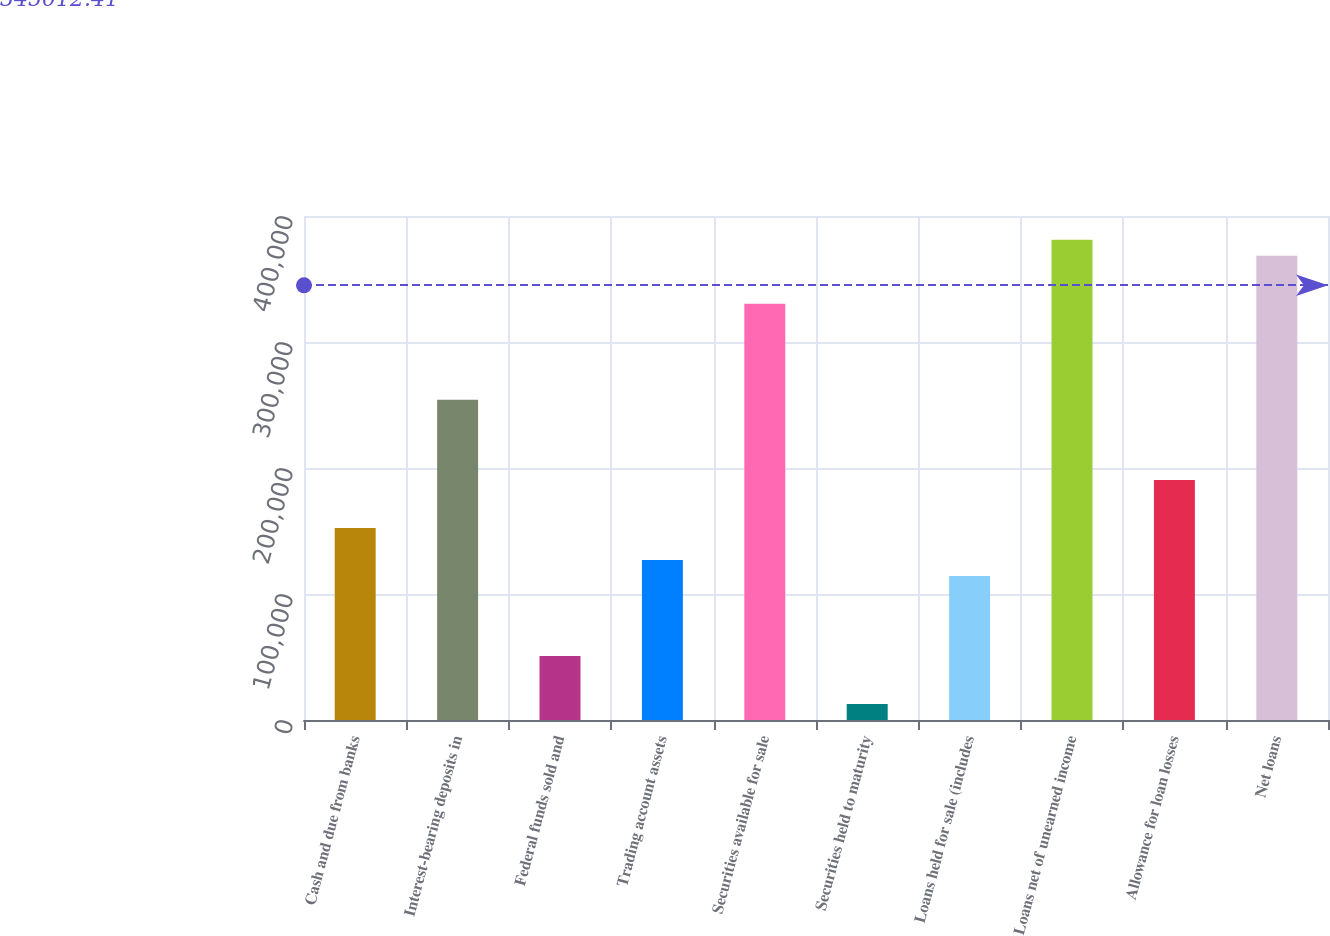Convert chart. <chart><loc_0><loc_0><loc_500><loc_500><bar_chart><fcel>Cash and due from banks<fcel>Interest-bearing deposits in<fcel>Federal funds sold and<fcel>Trading account assets<fcel>Securities available for sale<fcel>Securities held to maturity<fcel>Loans held for sale (includes<fcel>Loans net of unearned income<fcel>Allowance for loan losses<fcel>Net loans<nl><fcel>152457<fcel>254087<fcel>50827.8<fcel>127050<fcel>330309<fcel>12716.7<fcel>114346<fcel>381124<fcel>190568<fcel>368420<nl></chart> 